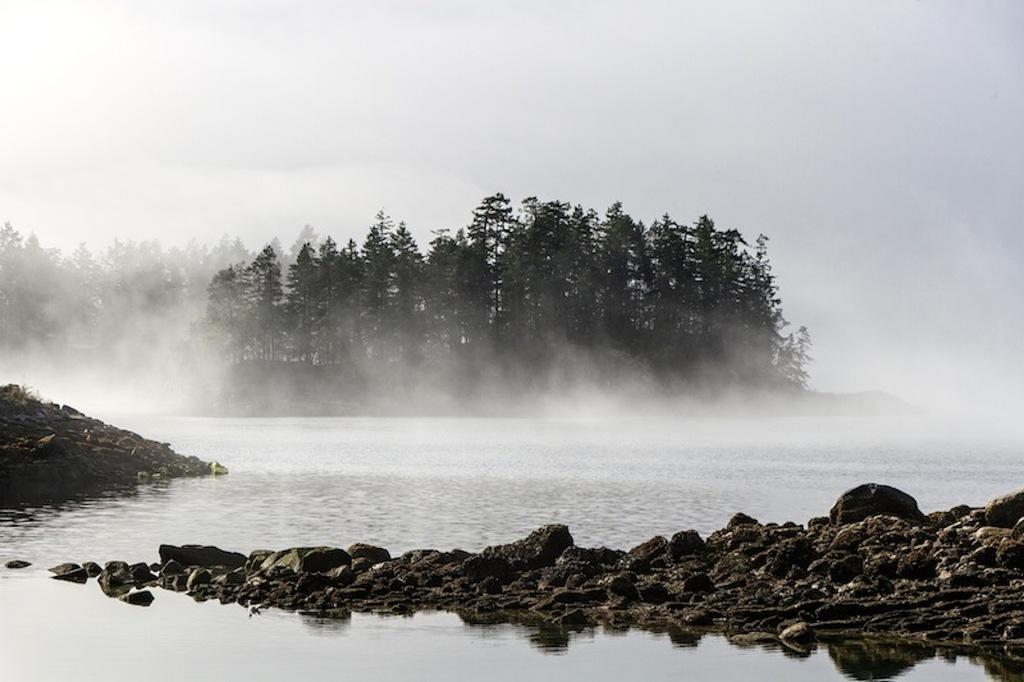How would you summarize this image in a sentence or two? In this picture we can see water at the bottom, we can see soil and rocks here, in the background there are some trees, we can see fog here, there is sky at the top of the picture. 